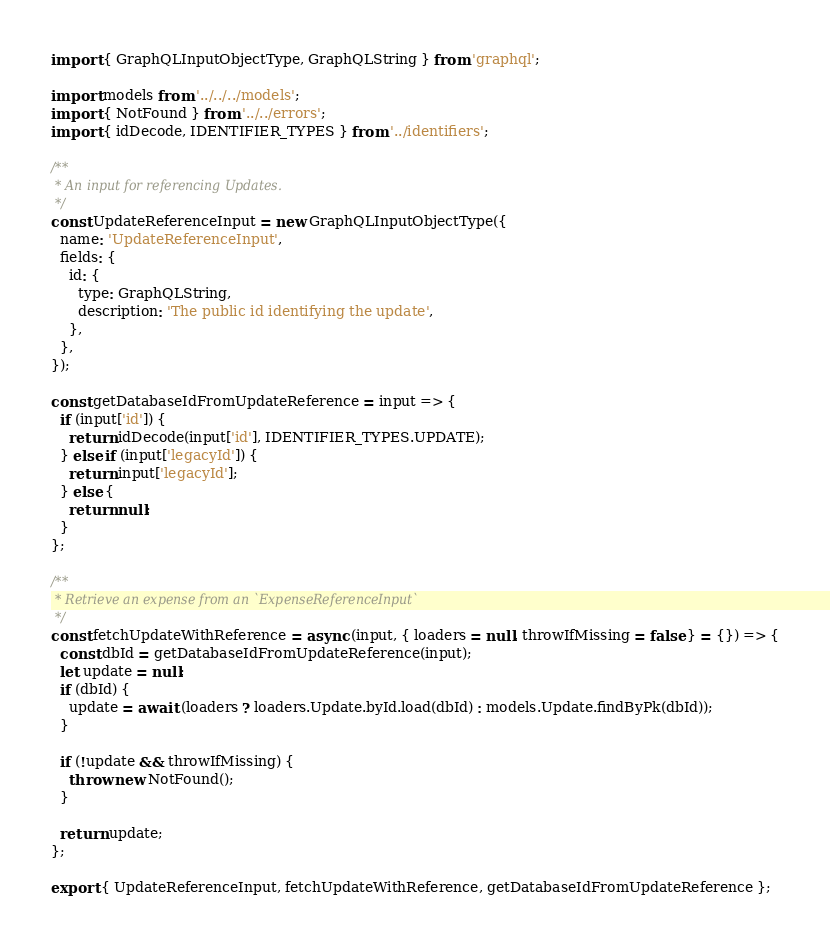<code> <loc_0><loc_0><loc_500><loc_500><_JavaScript_>import { GraphQLInputObjectType, GraphQLString } from 'graphql';

import models from '../../../models';
import { NotFound } from '../../errors';
import { idDecode, IDENTIFIER_TYPES } from '../identifiers';

/**
 * An input for referencing Updates.
 */
const UpdateReferenceInput = new GraphQLInputObjectType({
  name: 'UpdateReferenceInput',
  fields: {
    id: {
      type: GraphQLString,
      description: 'The public id identifying the update',
    },
  },
});

const getDatabaseIdFromUpdateReference = input => {
  if (input['id']) {
    return idDecode(input['id'], IDENTIFIER_TYPES.UPDATE);
  } else if (input['legacyId']) {
    return input['legacyId'];
  } else {
    return null;
  }
};

/**
 * Retrieve an expense from an `ExpenseReferenceInput`
 */
const fetchUpdateWithReference = async (input, { loaders = null, throwIfMissing = false } = {}) => {
  const dbId = getDatabaseIdFromUpdateReference(input);
  let update = null;
  if (dbId) {
    update = await (loaders ? loaders.Update.byId.load(dbId) : models.Update.findByPk(dbId));
  }

  if (!update && throwIfMissing) {
    throw new NotFound();
  }

  return update;
};

export { UpdateReferenceInput, fetchUpdateWithReference, getDatabaseIdFromUpdateReference };
</code> 